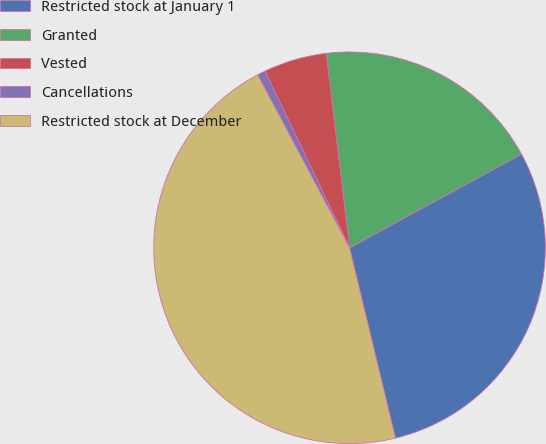Convert chart to OTSL. <chart><loc_0><loc_0><loc_500><loc_500><pie_chart><fcel>Restricted stock at January 1<fcel>Granted<fcel>Vested<fcel>Cancellations<fcel>Restricted stock at December<nl><fcel>29.17%<fcel>18.96%<fcel>5.2%<fcel>0.67%<fcel>46.0%<nl></chart> 